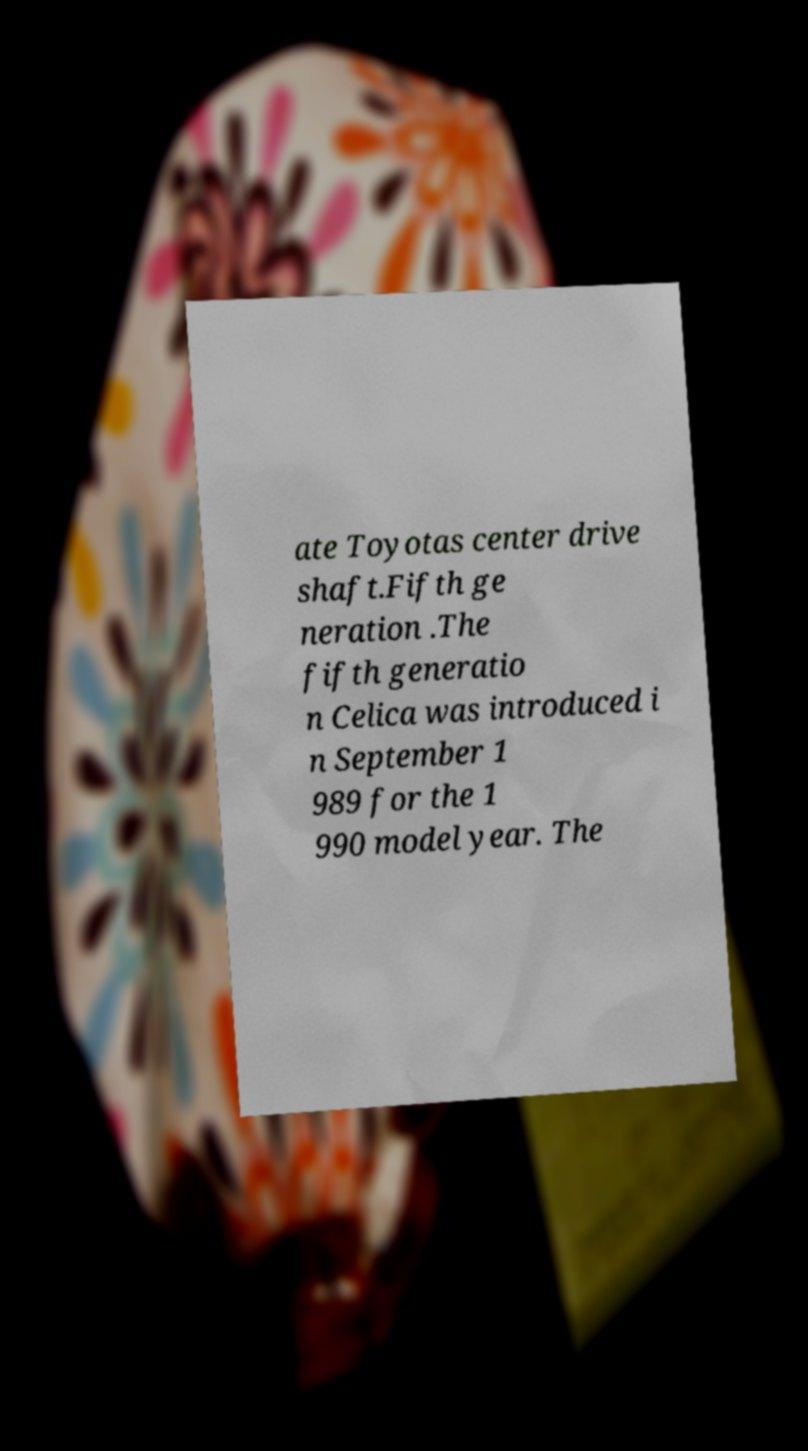Can you accurately transcribe the text from the provided image for me? ate Toyotas center drive shaft.Fifth ge neration .The fifth generatio n Celica was introduced i n September 1 989 for the 1 990 model year. The 